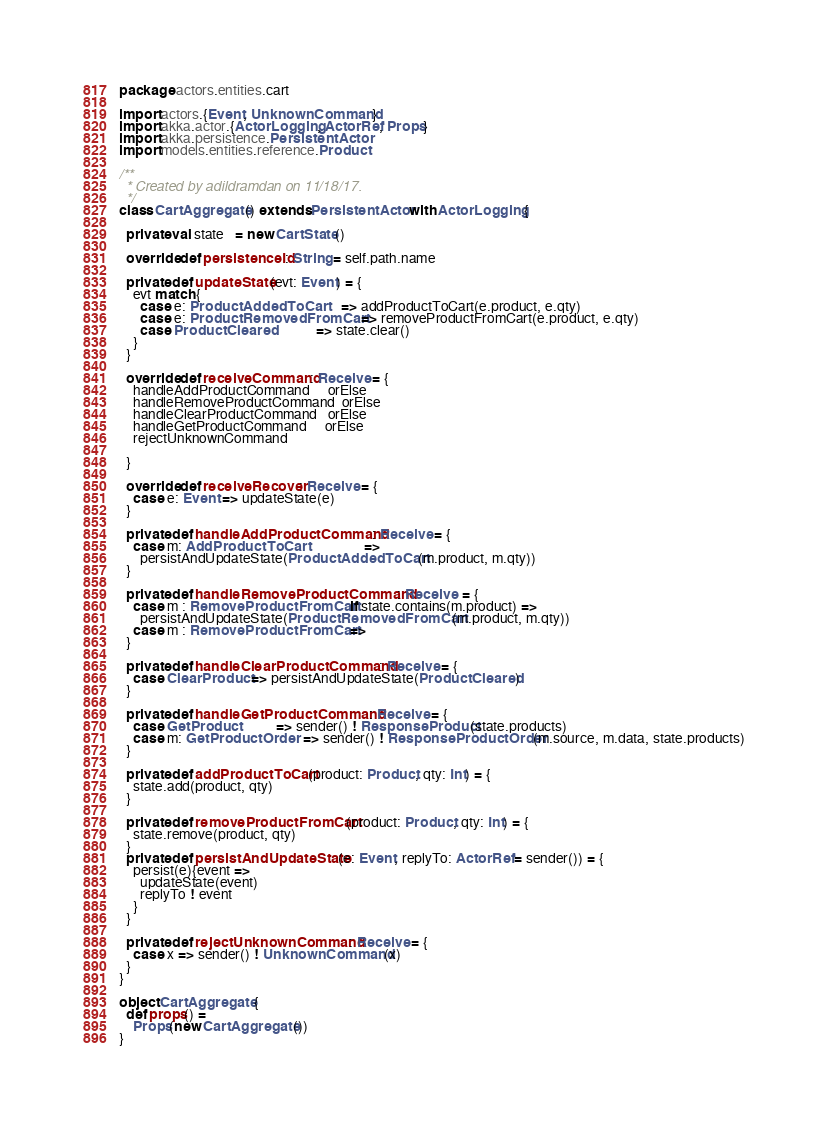Convert code to text. <code><loc_0><loc_0><loc_500><loc_500><_Scala_>package actors.entities.cart

import actors.{Event, UnknownCommand}
import akka.actor.{ActorLogging, ActorRef, Props}
import akka.persistence.PersistentActor
import models.entities.reference.Product

/**
  * Created by adildramdan on 11/18/17.
  */
class CartAggregate() extends PersistentActor with ActorLogging {

  private val state   = new CartState()

  override def persistenceId: String = self.path.name

  private def updateState(evt: Event) = {
    evt match {
      case e: ProductAddedToCart      => addProductToCart(e.product, e.qty)
      case e: ProductRemovedFromCart  => removeProductFromCart(e.product, e.qty)
      case ProductCleared             => state.clear()
    }
  }

  override def receiveCommand: Receive = {
    handleAddProductCommand     orElse
    handleRemoveProductCommand  orElse
    handleClearProductCommand   orElse
    handleGetProductCommand     orElse
    rejectUnknownCommand

  }

  override def receiveRecover: Receive = {
    case e: Event => updateState(e)
  }

  private def handleAddProductCommand: Receive = {
    case m: AddProductToCart                  =>
      persistAndUpdateState(ProductAddedToCart(m.product, m.qty))
  }

  private def handleRemoveProductCommand: Receive  = {
    case m : RemoveProductFromCart if state.contains(m.product) =>
      persistAndUpdateState(ProductRemovedFromCart(m.product, m.qty))
    case m : RemoveProductFromCart =>
  }

  private def handleClearProductCommand: Receive = {
    case ClearProduct => persistAndUpdateState(ProductCleared)
  }

  private def handleGetProductCommand: Receive = {
    case GetProduct           => sender() ! ResponseProduct(state.products)
    case m: GetProductOrder   => sender() ! ResponseProductOrder(m.source, m.data, state.products)
  }

  private def addProductToCart(product: Product, qty: Int) = {
    state.add(product, qty)
  }

  private def removeProductFromCart(product: Product, qty: Int) = {
    state.remove(product, qty)
  }
  private def persistAndUpdateState(e: Event, replyTo: ActorRef = sender()) = {
    persist(e){event =>
      updateState(event)
      replyTo ! event
    }
  }

  private def rejectUnknownCommand: Receive = {
    case x => sender() ! UnknownCommand(x)
  }
}

object CartAggregate {
  def props() =
    Props(new CartAggregate())
}</code> 